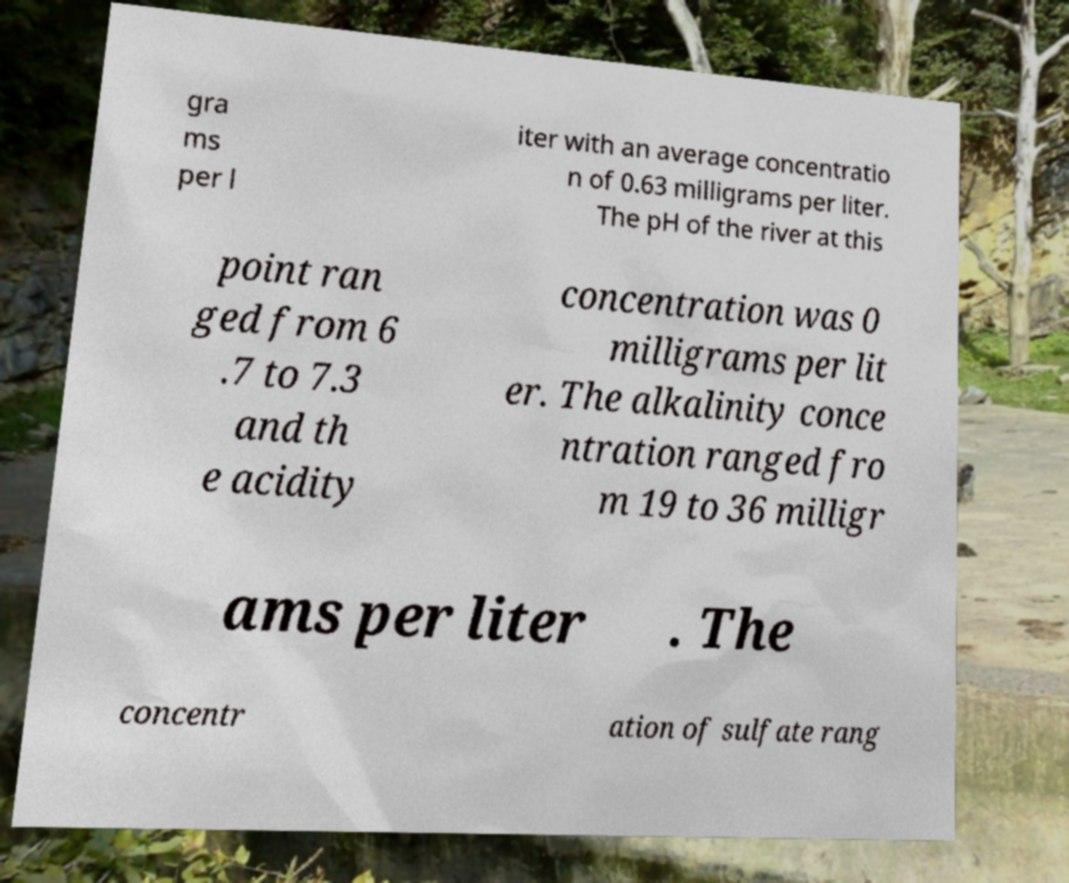Can you accurately transcribe the text from the provided image for me? gra ms per l iter with an average concentratio n of 0.63 milligrams per liter. The pH of the river at this point ran ged from 6 .7 to 7.3 and th e acidity concentration was 0 milligrams per lit er. The alkalinity conce ntration ranged fro m 19 to 36 milligr ams per liter . The concentr ation of sulfate rang 